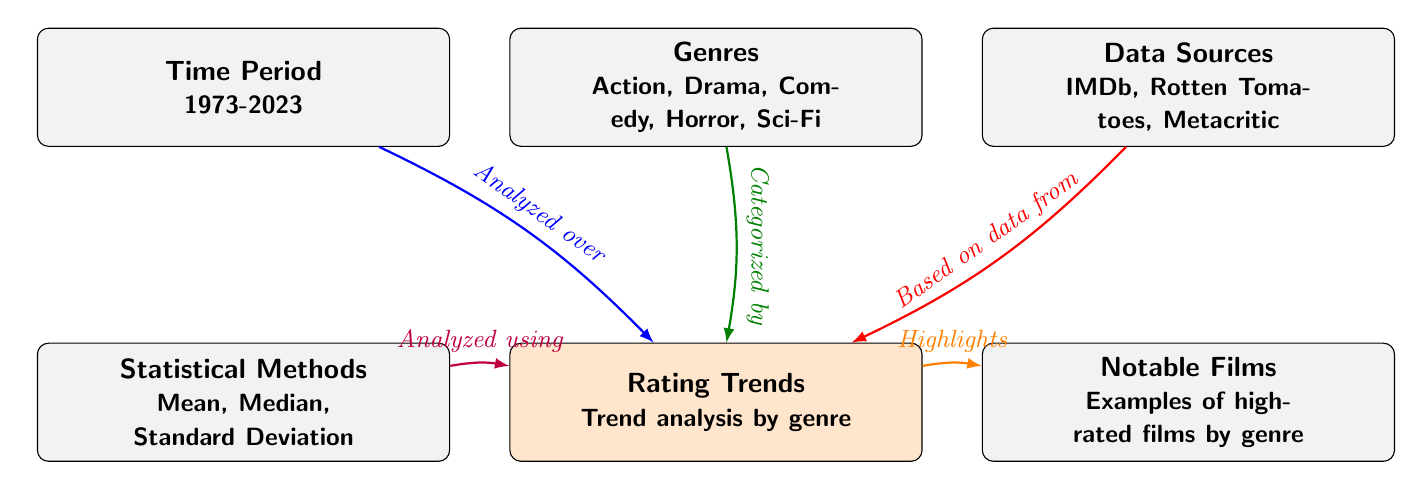What are the time periods analyzed in the diagram? The diagram clearly states "Time Period" with the subtext "1973-2023" in node 1. This indicates the range of years covered in the analysis.
Answer: 1973-2023 How many genres are mentioned in the diagram? Node 2 lists the genres: Action, Drama, Comedy, Horror, Sci-Fi. By counting these, we find there are a total of five genres included.
Answer: 5 What is the main statistical method used for analysis? In node 4, the labeled "Statistical Methods" lists several methods, but the title itself implies that mean, median, and standard deviation are the primary ones used. Since these are all mentioned together, we can denote them as the main methods.
Answer: Mean, Median, Standard Deviation Which data sources are used in the analysis? In node 3, the diagram lists "IMDb, Rotten Tomatoes, Metacritic" as the data sources utilized for the analysis, which provides specific references for the viewer.
Answer: IMDb, Rotten Tomatoes, Metacritic What does node 5 signify in the diagram? Node 5 is labeled "Rating Trends" and its subtext indicates that it focuses on "Trend analysis by genre". This node serves as a crucial link between the data sources and the notable films figured in the analysis.
Answer: Rating Trends How do data sources connect to rating trends? The edge leading from node 3 ("Data Sources") to node 5 ("Rating Trends") is marked, indicating a relationship where data from these sources inform the analysis of rating trends. This connection shows the flow of information from source to trend analysis.
Answer: Based on data from What is highlighted in node 6? Node 6 is labeled "Notable Films", suggesting that it contains examples of highly-rated films categorized by genre. This node is the culmination of the data analysis reflected in node 5.
Answer: Notable Films How are the genres categorized in this diagram? The edge connecting node 2 ("Genres") to node 5 ("Rating Trends") indicates that the genres are categorized in relation to the trend analysis being conducted. This relationship implies that these genres are the basis for the trend evaluations made in the analysis.
Answer: Categorized by 